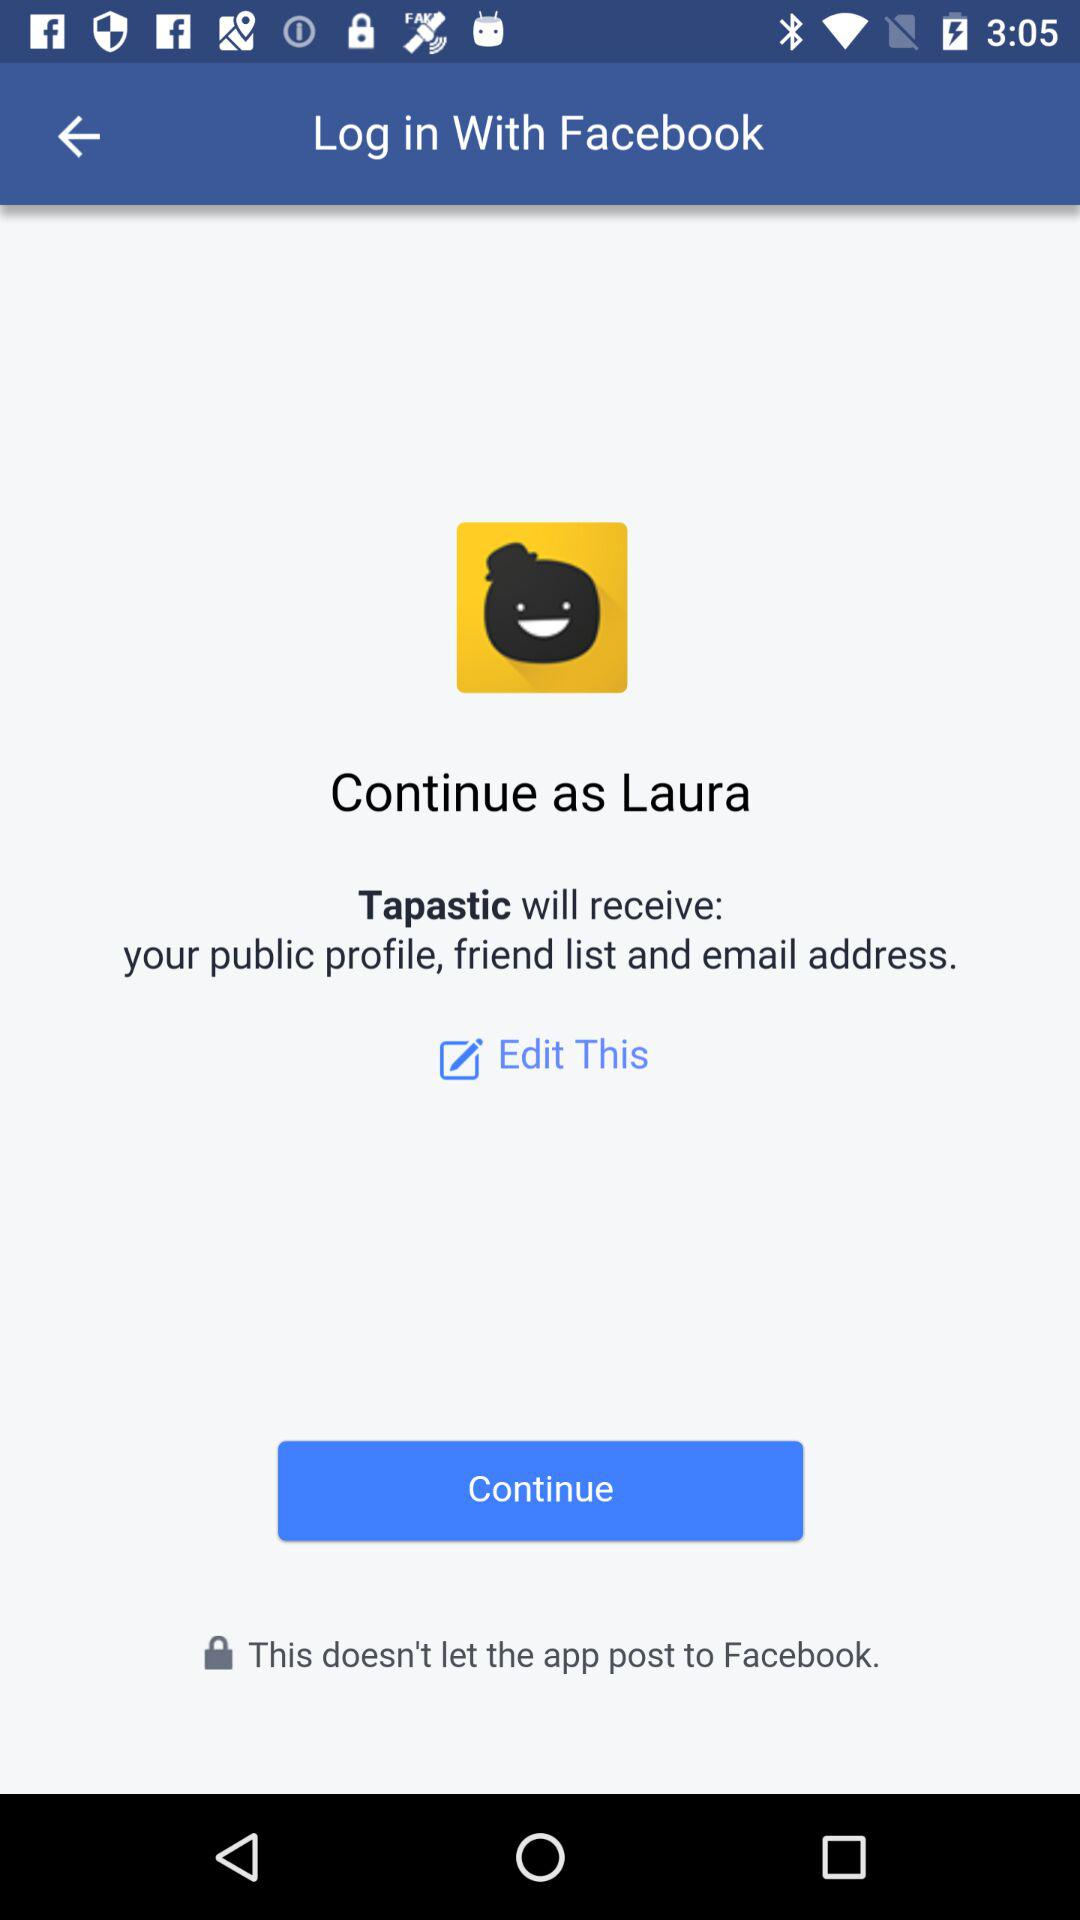What application can be used to log in? The application that can be used to log in is "Facebook". 